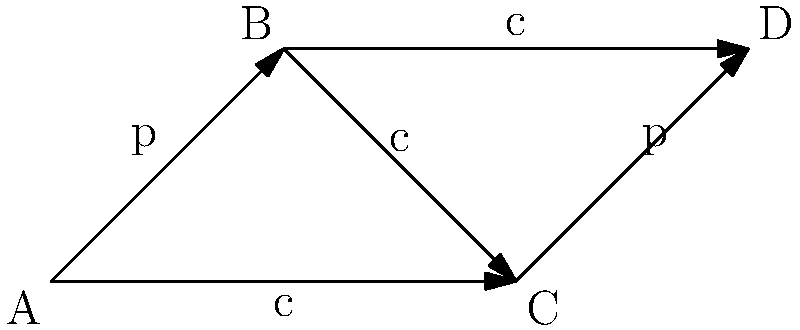In the context of representing genealogical relationships using Cayley graphs, consider the graph shown above. If 'p' represents "parent of" and 'c' represents "child of", what is the relationship between A and D? To determine the relationship between A and D, we need to follow the path from A to D in the Cayley graph:

1. Start at vertex A.
2. Follow the 'p' (parent of) edge from A to B.
3. Follow the 'c' (child of) edge from B to D.

The path from A to D is 'p' followed by 'c'. In genealogical terms:

- 'p' means "parent of"
- 'c' means "child of"

When we combine these relationships, we get:

A is the parent of someone (B) who is the child of D.

In genealogical terms, this means A is the sibling of D.
Answer: Sibling 